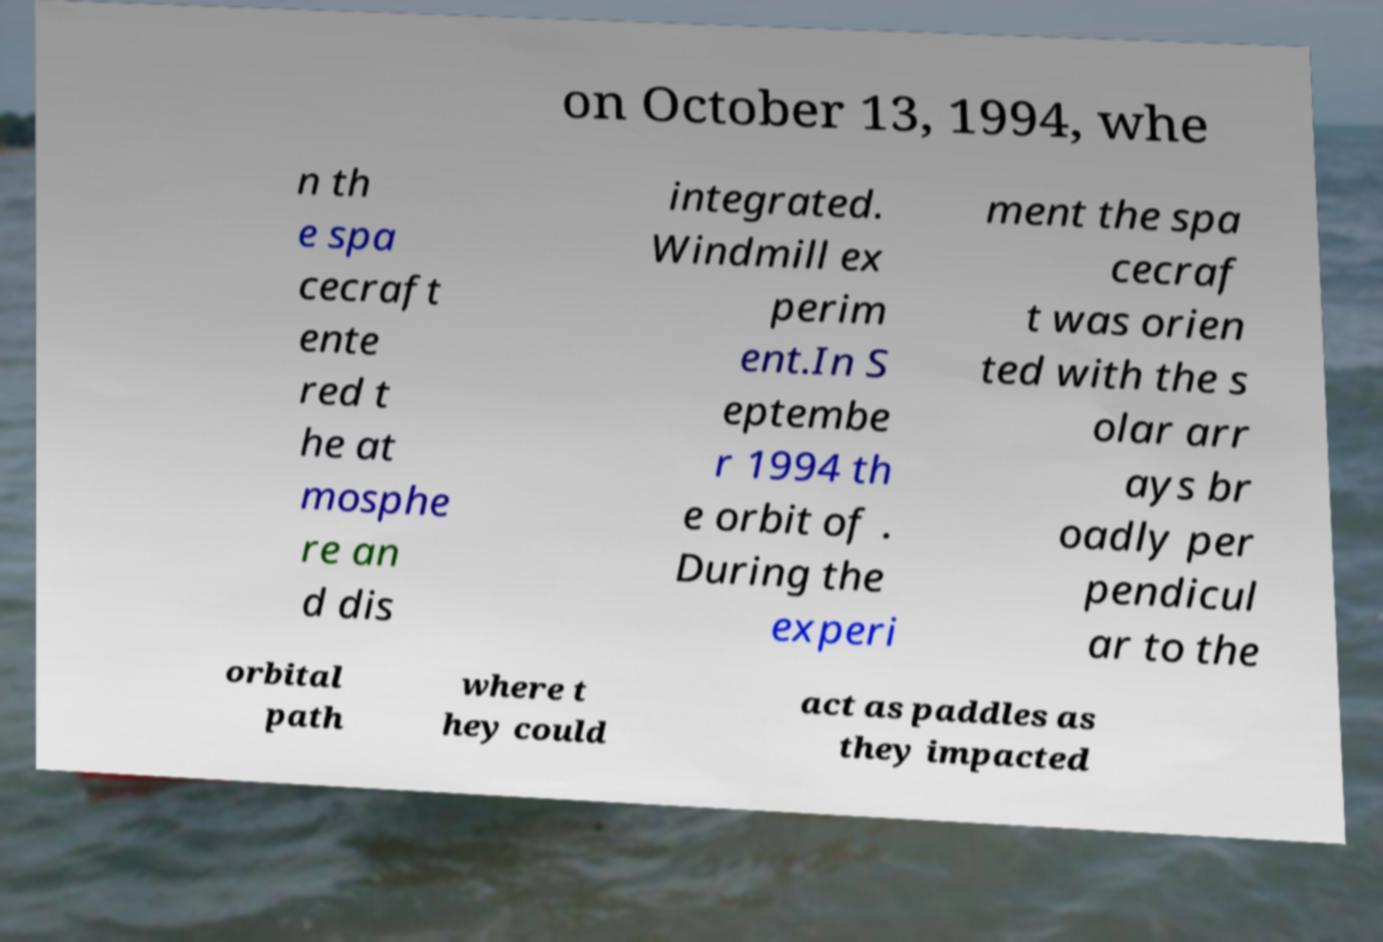Please identify and transcribe the text found in this image. on October 13, 1994, whe n th e spa cecraft ente red t he at mosphe re an d dis integrated. Windmill ex perim ent.In S eptembe r 1994 th e orbit of . During the experi ment the spa cecraf t was orien ted with the s olar arr ays br oadly per pendicul ar to the orbital path where t hey could act as paddles as they impacted 